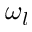Convert formula to latex. <formula><loc_0><loc_0><loc_500><loc_500>\omega _ { l }</formula> 